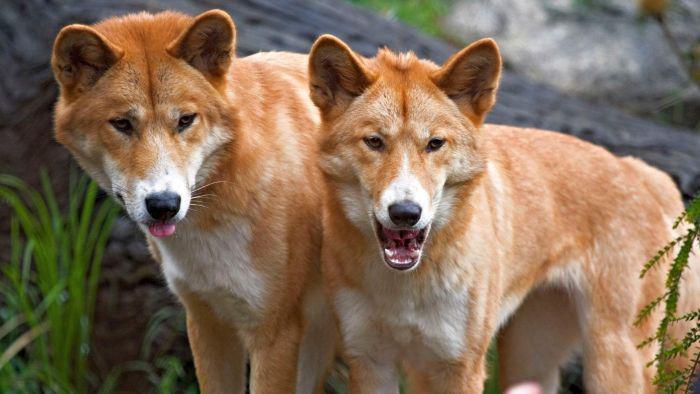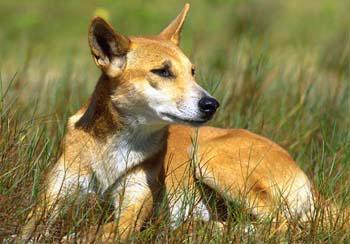The first image is the image on the left, the second image is the image on the right. Given the left and right images, does the statement "There are no more than 3 dogs in total." hold true? Answer yes or no. Yes. The first image is the image on the left, the second image is the image on the right. Examine the images to the left and right. Is the description "An image contains only one dog, which is standing on a rock gazing rightward." accurate? Answer yes or no. No. 